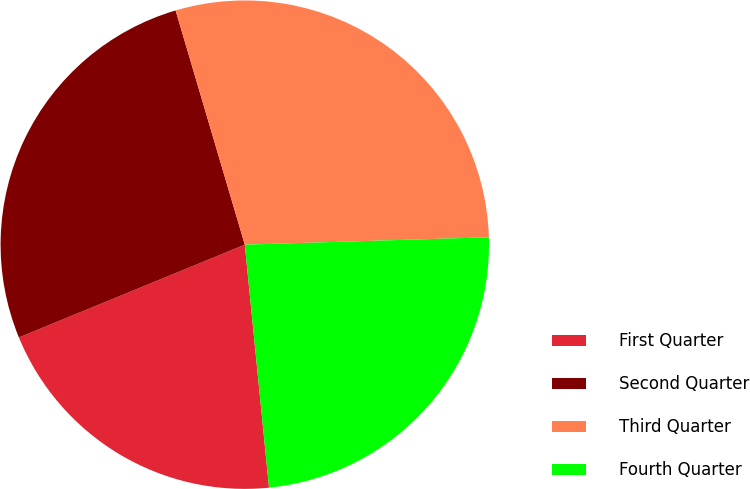Convert chart to OTSL. <chart><loc_0><loc_0><loc_500><loc_500><pie_chart><fcel>First Quarter<fcel>Second Quarter<fcel>Third Quarter<fcel>Fourth Quarter<nl><fcel>20.38%<fcel>26.63%<fcel>29.09%<fcel>23.9%<nl></chart> 